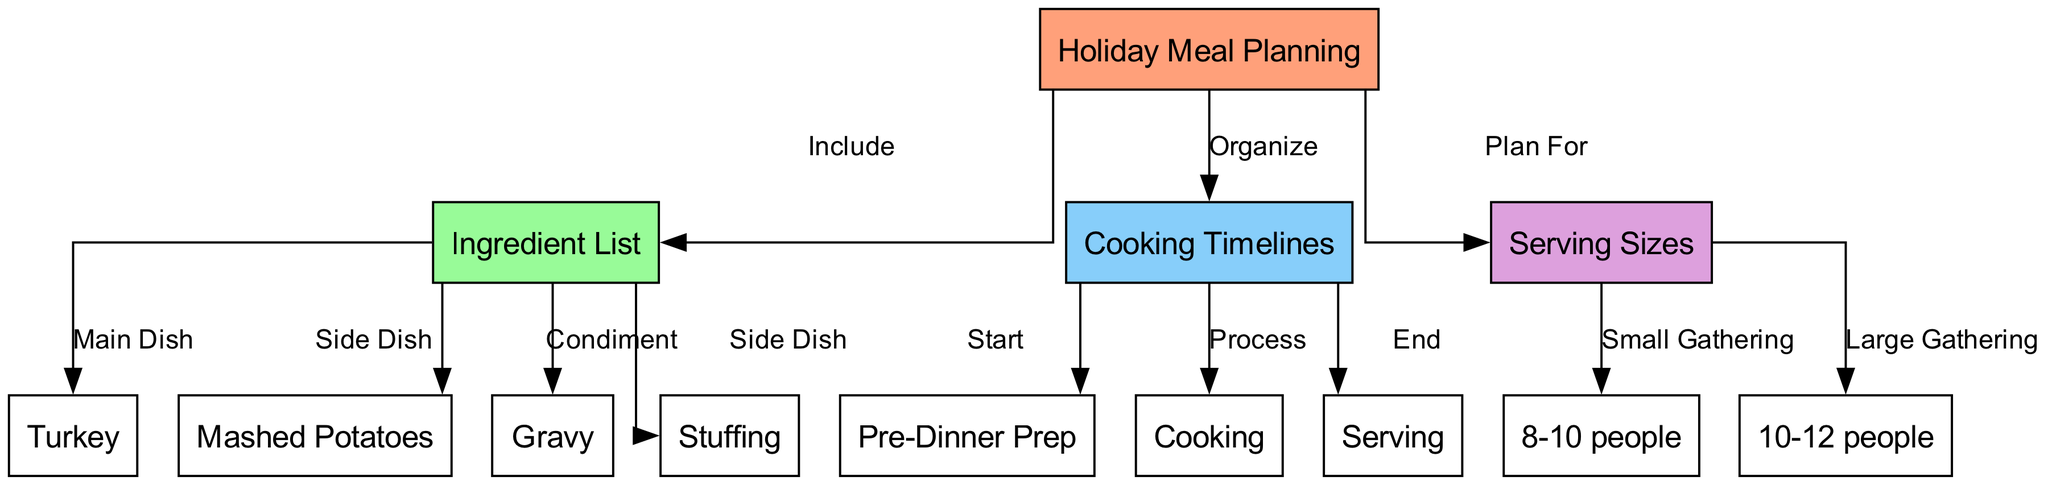What is the main dish in the ingredient list? The diagram indicates that the main dish is turkey, which is labeled under the ingredient list node.
Answer: Turkey How many nodes are there in total? Counting the nodes displayed in the diagram, there are 13 nodes represented.
Answer: 13 What is the relationship between "Holiday Meal Planning" and "Serving Sizes"? The diagram shows that "Holiday Meal Planning" plans for "Serving Sizes," indicating a direct relationship where meal planning includes consideration of serving sizes.
Answer: Plan For What is one side dish listed in the ingredient list? The ingredient list includes mashed potatoes as one of the side dishes available for the meal.
Answer: Mashed Potatoes Which stage comes after "Cooking" in the cooking timelines? After "Cooking," the process progresses to "Serving," which is the final stage in the timeline, emphasizing the sequence of meal preparation.
Answer: Serving For how many people is the meal planned if it's a large gathering? The diagram specifies that a large gathering typically accommodates 10-12 people based on the serving sizes defined.
Answer: 10-12 people What is the first step in the cooking timeline? The diagram indicates that the first step in the cooking timeline is "Pre-Dinner Prep," which sets the stage for the cooking process.
Answer: Pre-Dinner Prep Which condiment is included in the ingredient list? According to the ingredient list in the diagram, gravy is identified as the condiment for the meal.
Answer: Gravy What category does 'stuffing' fall under in the ingredient list? The diagram categorizes stuffing as a side dish, placing it alongside other side dishes like mashed potatoes.
Answer: Side Dish 